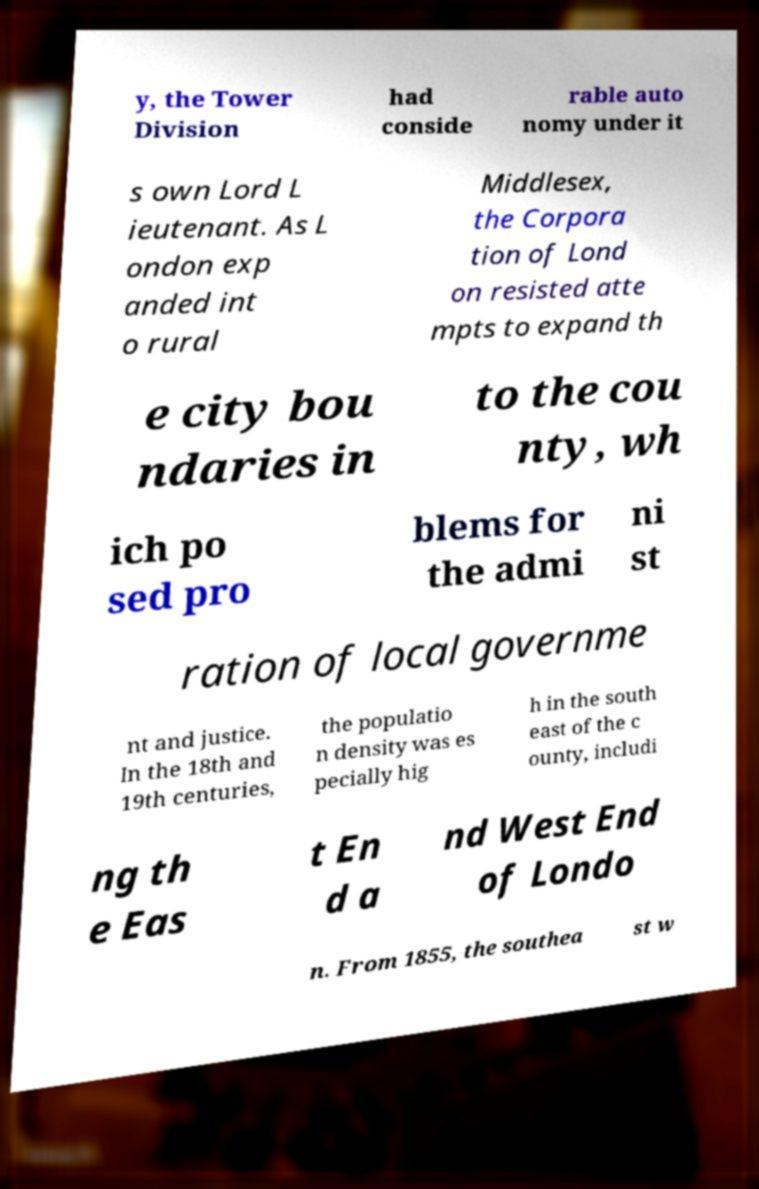I need the written content from this picture converted into text. Can you do that? y, the Tower Division had conside rable auto nomy under it s own Lord L ieutenant. As L ondon exp anded int o rural Middlesex, the Corpora tion of Lond on resisted atte mpts to expand th e city bou ndaries in to the cou nty, wh ich po sed pro blems for the admi ni st ration of local governme nt and justice. In the 18th and 19th centuries, the populatio n density was es pecially hig h in the south east of the c ounty, includi ng th e Eas t En d a nd West End of Londo n. From 1855, the southea st w 